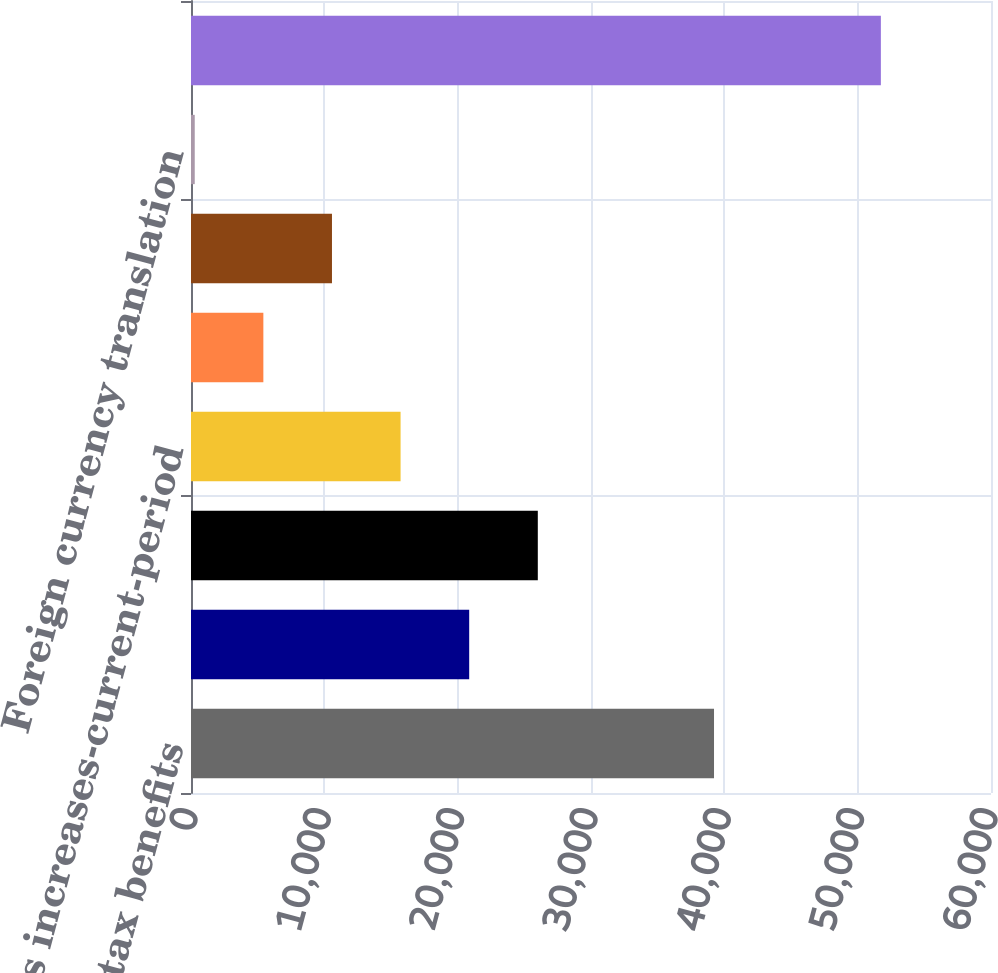Convert chart. <chart><loc_0><loc_0><loc_500><loc_500><bar_chart><fcel>Unrecognized tax benefits<fcel>Gross increases-tax positions<fcel>Gross decreases-tax positions<fcel>Gross increases-current-period<fcel>Settlements<fcel>Lapse of statute of<fcel>Foreign currency translation<fcel>Unrecognized tax benefits end<nl><fcel>39226<fcel>20864.6<fcel>26010.5<fcel>15718.7<fcel>5426.9<fcel>10572.8<fcel>281<fcel>51740<nl></chart> 